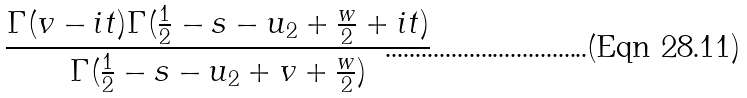Convert formula to latex. <formula><loc_0><loc_0><loc_500><loc_500>\frac { \Gamma ( v - i t ) \Gamma ( \frac { 1 } { 2 } - s - u _ { 2 } + \frac { w } { 2 } + i t ) } { \Gamma ( \frac { 1 } { 2 } - s - u _ { 2 } + v + \frac { w } { 2 } ) }</formula> 